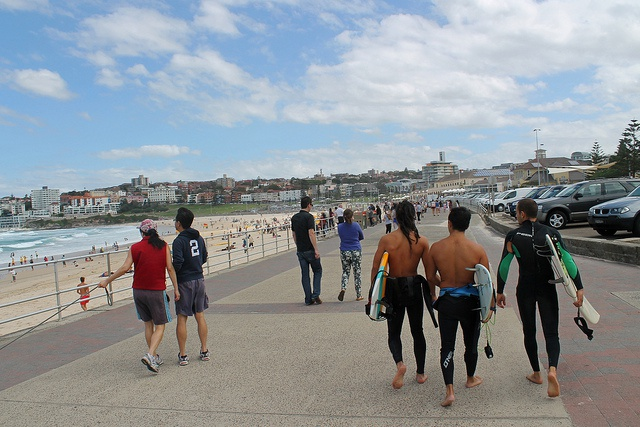Describe the objects in this image and their specific colors. I can see people in darkgray, black, maroon, and gray tones, people in darkgray, gray, tan, and lightgray tones, people in darkgray, black, maroon, and brown tones, people in darkgray, black, gray, and maroon tones, and people in darkgray, maroon, black, gray, and tan tones in this image. 